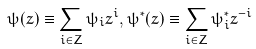<formula> <loc_0><loc_0><loc_500><loc_500>\psi ( z ) \equiv \sum _ { i \in Z } \psi _ { i } z ^ { i } , \psi ^ { \ast } ( z ) \equiv \sum _ { i \in Z } \psi _ { i } ^ { \ast } z ^ { - i }</formula> 